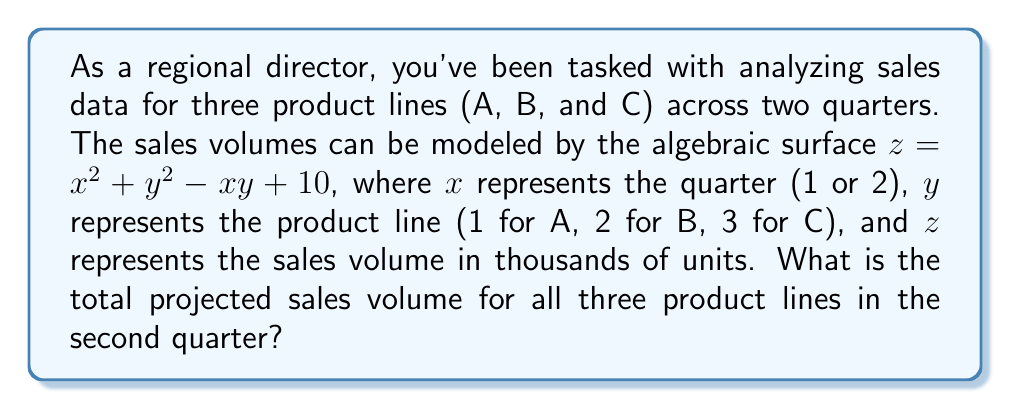Show me your answer to this math problem. Let's approach this step-by-step:

1) We're looking at the second quarter, so $x = 2$ for all calculations.

2) We need to calculate the sales volume for each product line in the second quarter:

   For product A (y = 1):
   $z = 2^2 + 1^2 - 2(1) + 10 = 4 + 1 - 2 + 10 = 13$

   For product B (y = 2):
   $z = 2^2 + 2^2 - 2(2) + 10 = 4 + 4 - 4 + 10 = 14$

   For product C (y = 3):
   $z = 2^2 + 3^2 - 2(3) + 10 = 4 + 9 - 6 + 10 = 17$

3) Each $z$ value represents thousands of units. So, the sales volumes are:
   Product A: 13,000 units
   Product B: 14,000 units
   Product C: 17,000 units

4) To get the total projected sales volume, we sum these values:
   13,000 + 14,000 + 17,000 = 44,000 units
Answer: 44,000 units 